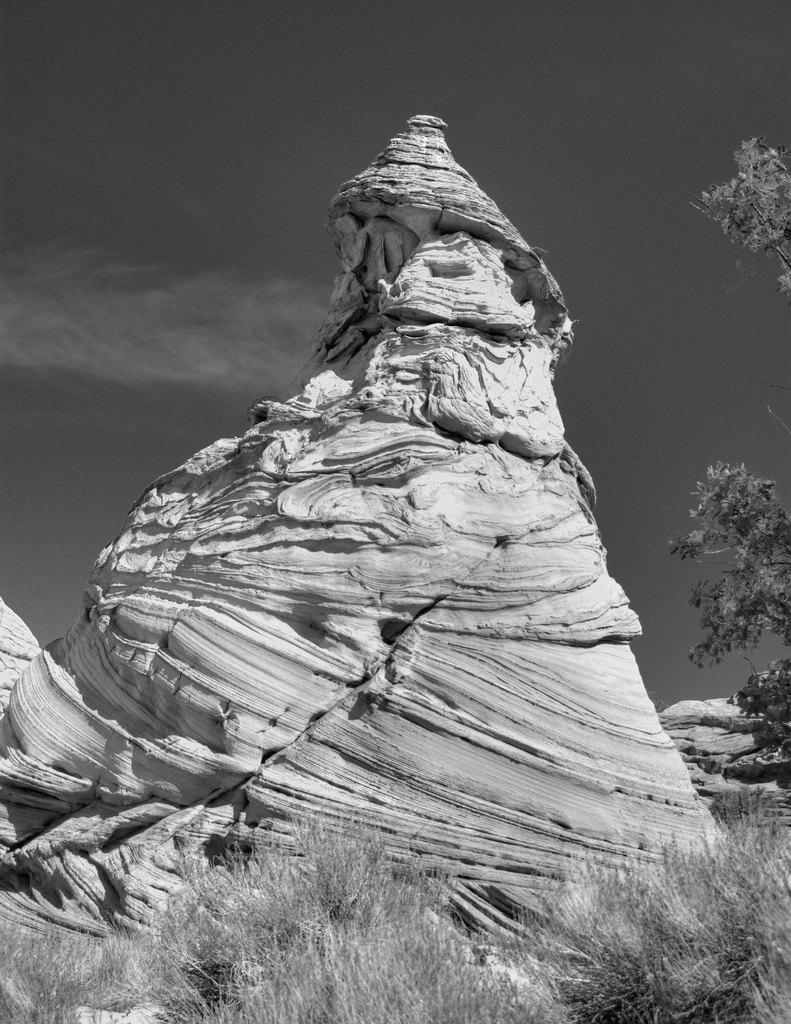In one or two sentences, can you explain what this image depicts? In this image I can see grass, plants, trees, mountains and the sky. This image is taken may be during night. 